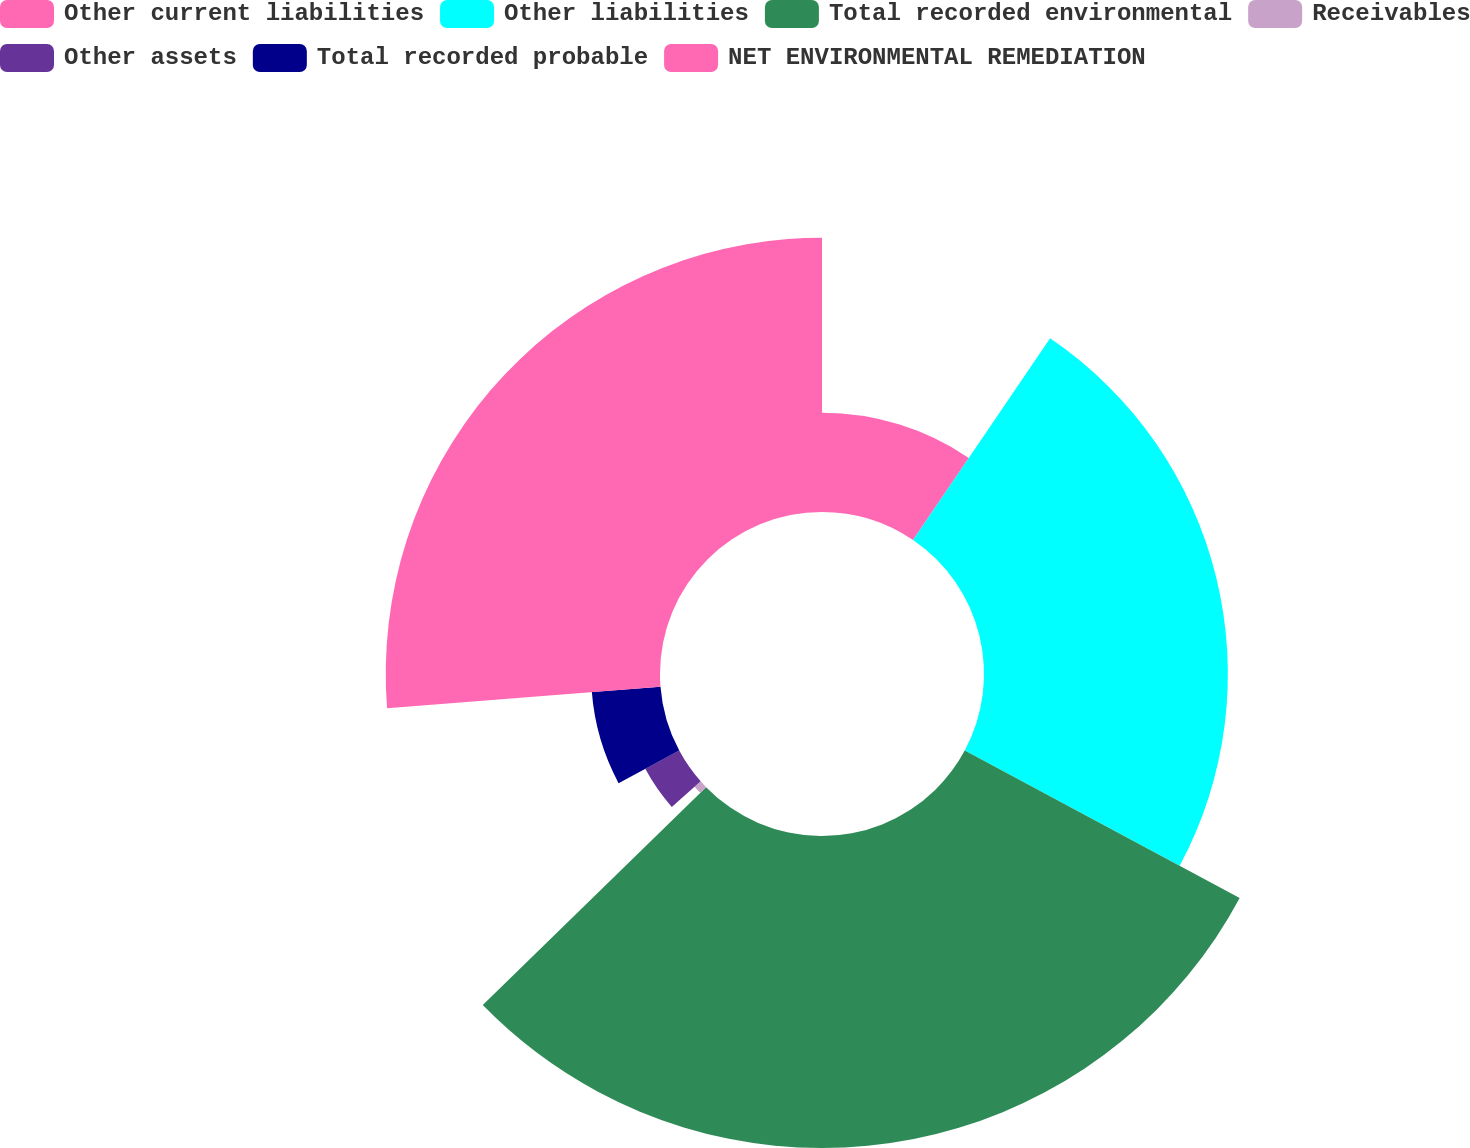Convert chart to OTSL. <chart><loc_0><loc_0><loc_500><loc_500><pie_chart><fcel>Other current liabilities<fcel>Other liabilities<fcel>Total recorded environmental<fcel>Receivables<fcel>Other assets<fcel>Total recorded probable<fcel>NET ENVIRONMENTAL REMEDIATION<nl><fcel>9.5%<fcel>23.34%<fcel>29.86%<fcel>0.78%<fcel>3.69%<fcel>6.59%<fcel>26.25%<nl></chart> 